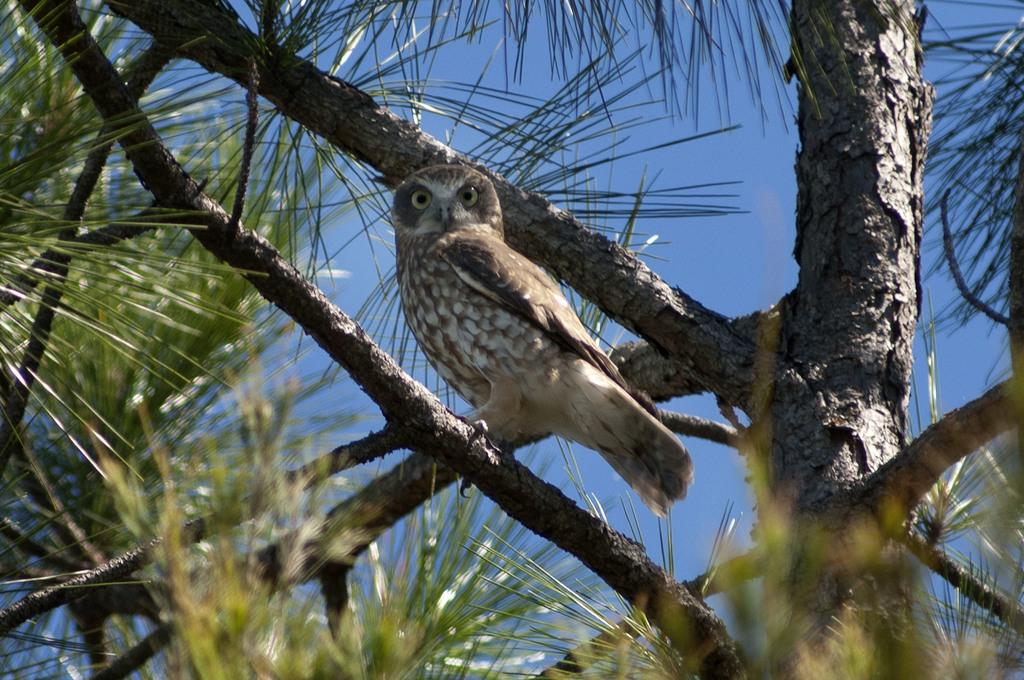What animal can be seen in the picture? There is an owl in the picture. Where is the owl located? The owl is sitting on the stem of a tree. What is surrounding the owl? There are leaves around the owl. What is the condition of the sky in the picture? The sky is clear in the picture. What type of scissors can be seen in the picture? There are no scissors present in the picture; it features an owl sitting on a tree stem surrounded by leaves. Can you describe the wave pattern in the picture? There is no wave pattern present in the picture; it is a still image of an owl on a tree. 